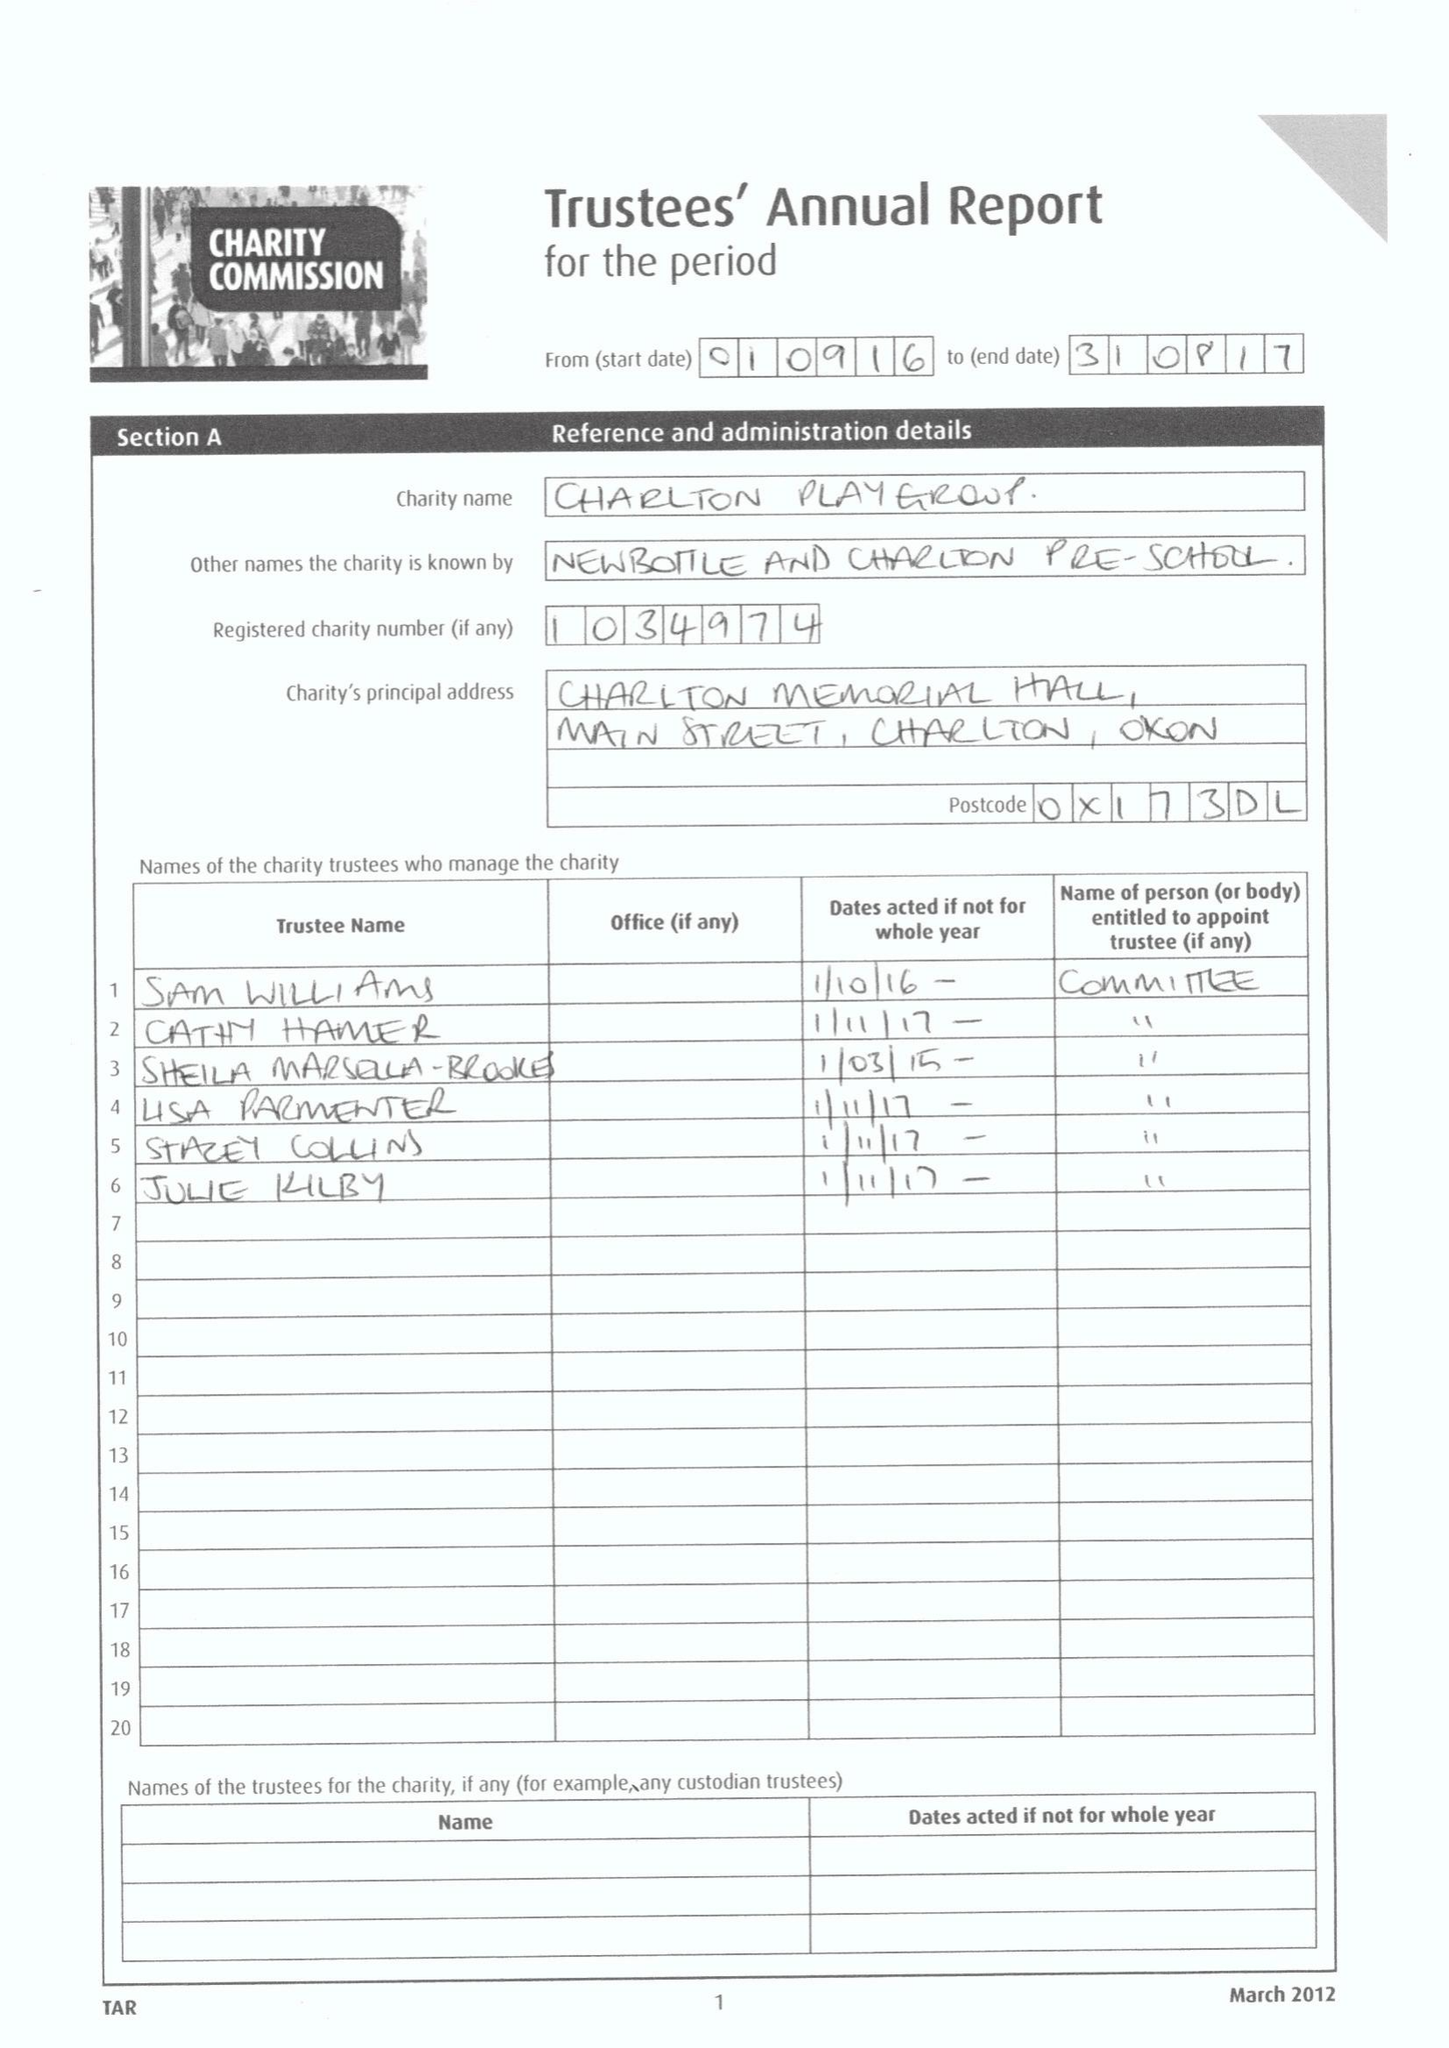What is the value for the charity_number?
Answer the question using a single word or phrase. 1034974 